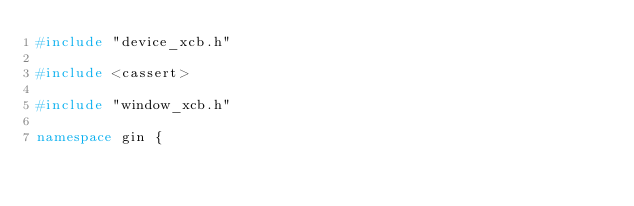Convert code to text. <code><loc_0><loc_0><loc_500><loc_500><_C++_>#include "device_xcb.h"

#include <cassert>

#include "window_xcb.h"

namespace gin {</code> 